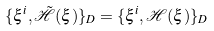Convert formula to latex. <formula><loc_0><loc_0><loc_500><loc_500>\{ \xi ^ { i } , { \tilde { \mathcal { H } } } ( \xi ) \} _ { D } = \{ \xi ^ { i } , \mathcal { H } ( \xi ) \} _ { D }</formula> 